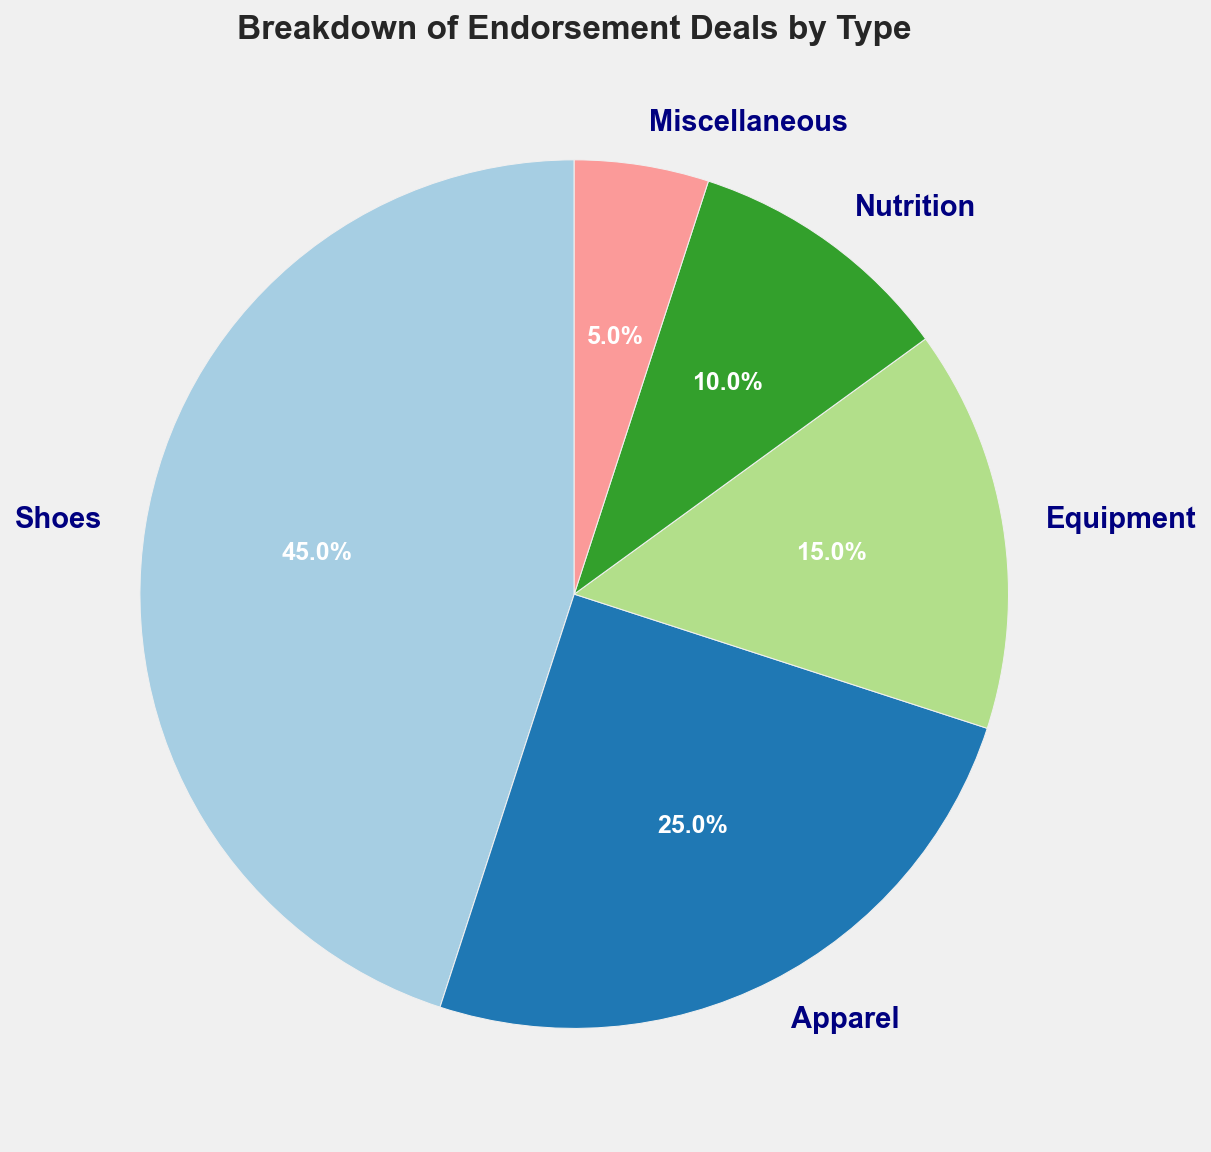What is the second most significant type of endorsement deal by percentage? The second largest segment after shoes is the 25% segment for Apparel.
Answer: Apparel On visual inspection, what slice color represents the endorsement deals for shoes? The pie chart uses the 'Paired' colormap, and by visual inspection, the shoes segment is typically represented by the first color in the scheme, which could be purple.
Answer: Purple How many types of endorsement deals collectively account for more than 50%? Shoes (45%) and Apparel (25%) together make 70%, which is more than 50%.
Answer: Two types Which type of endorsement deal has the smallest percentage share? From the chart, Miscellaneous has the smallest share with 5%.
Answer: Miscellaneous If apparel endorsement deals increased by 10 percentage points, would they surpass shoes in share? The new percentage for Apparel would be 25% + 10% = 35%, still less than the 45% for Shoes.
Answer: No What percentage sum do the equipment and nutrition endorsement deals represent? Equipment has 15% and Nutrition has 10%. Summing these gives 15% + 10% = 25%.
Answer: 25% Between equipment and nutrition, which type has a higher share? Equipment has 15%, which is greater than the 10% share for Nutrition.
Answer: Equipment Considering all endorsement deal types, what is the average percentage share? Sum all percentages (45 + 25 + 15 + 10 + 5 = 100) and divide by 5 types, yielding an average of 100/5 = 20%.
Answer: 20% By how much percentage does the largest segment surpass the smallest one? Shoes (45%) - Miscellaneous (5%) = 40%.
Answer: 40% What combination of endorsement types equals exactly 50%? Apparel (25%) + Equipment (15%) + Nutrition (10%) = 50%.
Answer: Apparel, Equipment, and Nutrition 